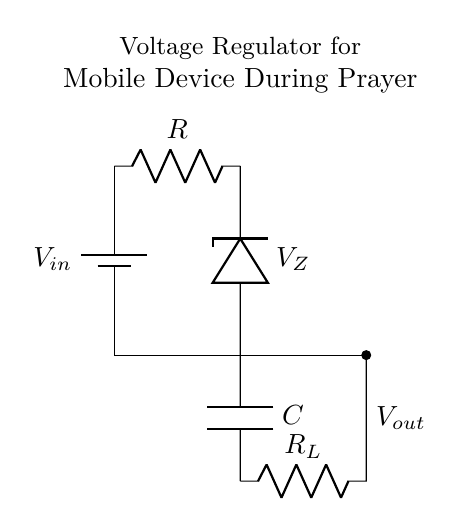What is the input voltage in this circuit? The input voltage is indicated by the battery symbol labeled as Vin. This is the voltage source that provides power to the circuit.
Answer: Vin What component regulates the output voltage? The zener diode is responsible for regulating the output voltage. It maintains a consistent voltage level across the load despite fluctuations in the input voltage.
Answer: Zener diode What is the purpose of the capacitor in this circuit? The capacitor is used to smooth out the output voltage by filtering any ripples or noise, ensuring a stable power supply to the mobile device during operation.
Answer: Smoothing What is the value of the load resistor denoted in the circuit? The load resistor is indicated as RL, which is a variable value designed to represent the load connected to the mobile device; the actual value is not specified in the diagram.
Answer: RL How does the zener diode function in this circuit during prayer sessions? The zener diode acts as a voltage clamp, allowing only a specific voltage level to pass through while blocking higher voltages, thereby ensuring that the mobile device receives a steady voltage, preventing damage and interruptions during prayer sessions.
Answer: Voltage clamp What could happen if the input voltage exceeds the zener diode's breakdown voltage? If the input voltage exceeds the zener diode's breakdown voltage, the diode will conduct in reverse, potentially leading to excessive current flow which could damage the zener diode or affect the connected mobile device.
Answer: Damage risk What is the flow direction of current in this circuit? Current flows from the battery through the resistor to the zener diode, then to the load and finally back to the ground, completing the circuit.
Answer: From battery to ground 